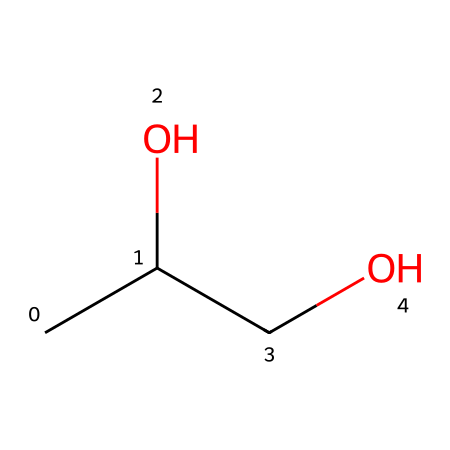What is the molecular formula of this compound? The SMILES representation CC(O)CO can be broken down to identify the atoms present: there are 3 carbon (C) atoms, 8 hydrogen (H) atoms, and 2 oxygen (O) atoms, forming the molecular formula C3H8O2.
Answer: C3H8O2 How many hydroxyl groups (–OH) are in this chemical structure? The hydroxyl group is present at the –OH portions seen in the structure, and analyzing the SMILES shows there are two instances of this group.
Answer: 2 What is the common name of this compound? This chemical structure is most commonly known as propylene glycol, recognized for its use in various products including e-liquids.
Answer: propylene glycol How many total atoms are in this compound? By summing all the atoms present as deduced from the molecular formula C3H8O2, which includes 3 carbon, 8 hydrogen, and 2 oxygen atoms: 3 + 8 + 2 = 13.
Answer: 13 What type of chemical is propylene glycol classified as? Propylene glycol is classified as a polyol, which refers to a type of alcohol with multiple hydroxyl groups in its structure, defining its properties and functions.
Answer: polyol Is this compound considered safe for ingestion? Propylene glycol is generally recognized as safe for ingestion by various health regulatory agencies, indicating its wide acceptance in food and other consumer products.
Answer: yes Does this chemical have any antimicrobial properties? Yes, propylene glycol has been noted to exhibit some antimicrobial properties, making it a useful preservative in certain applications, including e-liquids, by helping to inhibit bacterial growth.
Answer: yes 